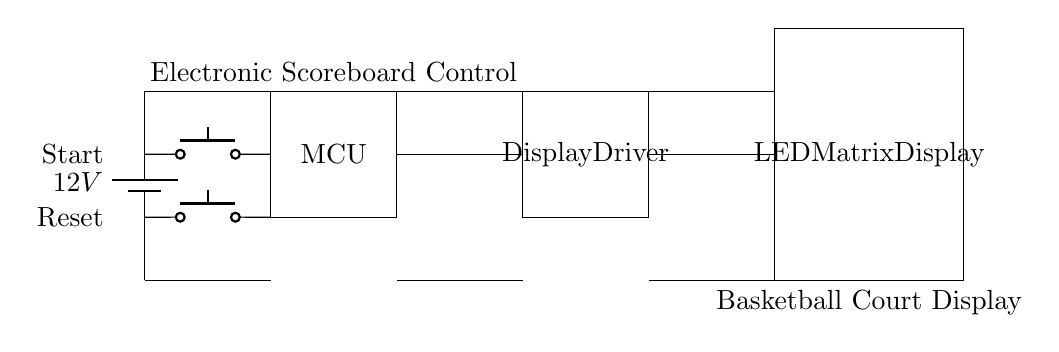What is the voltage of this circuit? The voltage source is labeled as 12V, which supplies the power to the entire circuit. Therefore, the voltage of this circuit is 12V.
Answer: 12V What components are present in the circuit? The circuit consists of a power supply (battery), a microcontroller (MCU), push buttons for Start and Reset inputs, a display driver, and an LED matrix display. These components are clearly labeled in the circuit diagram.
Answer: Battery, MCU, Push Buttons, Display Driver, LED Matrix How many push buttons are shown in the circuit? The circuit diagram explicitly shows two push buttons with labels for Start and Reset, indicating that there are two push buttons present in the circuit.
Answer: 2 What is the function of the Display Driver in this circuit? The Display Driver serves as an intermediary component that processes data from the microcontroller and drives the LED matrix display. This function is typical in display control circuits, where information needs to be visually presented.
Answer: To drive the LED matrix What connects the microcontroller to the display driver? There is a direct line connecting the microcontroller to the display driver, indicating that data is transferred from the MCU to the driver for further processing. This connection is crucial for the functionality of the scoreboard system.
Answer: A wire Why is there a Reset button in the circuit? The Reset button allows users to clear the current score or reset the scoreboard to a starting state. It is a common feature in electronic scoreboards, providing the ability to restart scoring in games or events.
Answer: To clear the score 